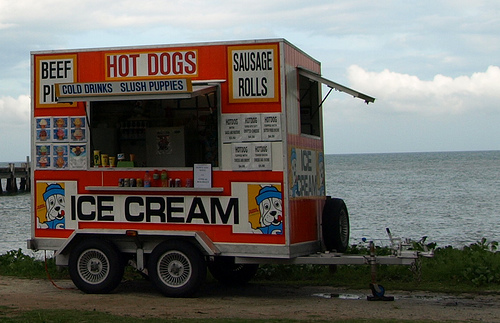<image>
Can you confirm if the van is in front of the sea? Yes. The van is positioned in front of the sea, appearing closer to the camera viewpoint. 